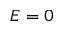Convert formula to latex. <formula><loc_0><loc_0><loc_500><loc_500>E = 0</formula> 